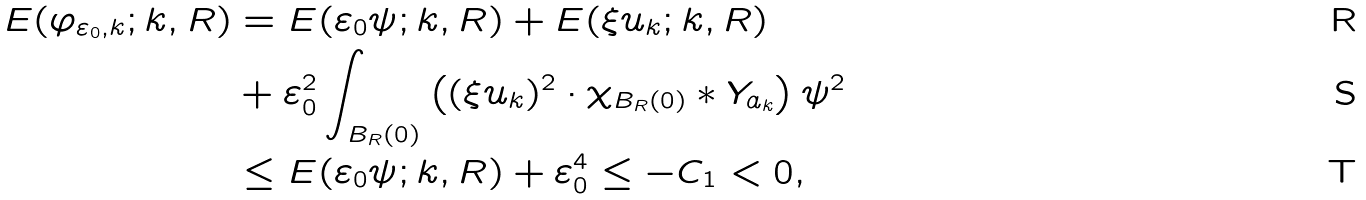Convert formula to latex. <formula><loc_0><loc_0><loc_500><loc_500>E ( \varphi _ { \varepsilon _ { 0 } , k } ; k , R ) & = E ( \varepsilon _ { 0 } \psi ; k , R ) + E ( \xi u _ { k } ; k , R ) \\ & + \varepsilon _ { 0 } ^ { 2 } \int _ { B _ { R } ( 0 ) } \left ( ( \xi u _ { k } ) ^ { 2 } \cdot \chi _ { B _ { R } ( 0 ) } * Y _ { a _ { k } } \right ) \psi ^ { 2 } \\ & \leq E ( \varepsilon _ { 0 } \psi ; k , R ) + \varepsilon _ { 0 } ^ { 4 } \leq - C _ { 1 } < 0 ,</formula> 